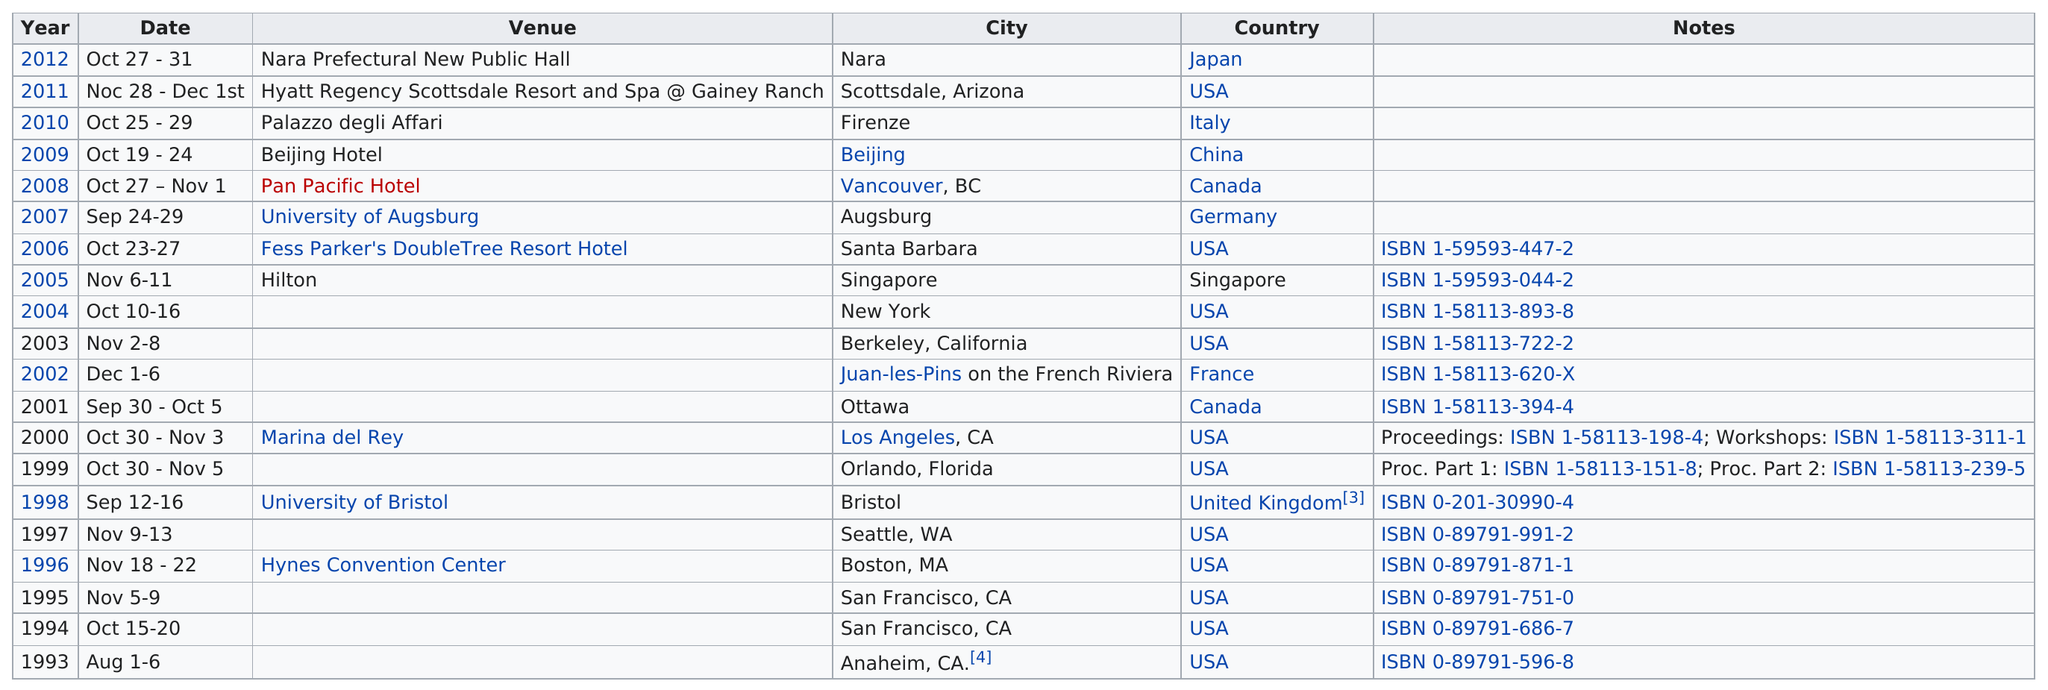Highlight a few significant elements in this photo. In 2012, the previous ACM Multimedia Workshop was held at the Nara Prefectural New Public Hall. In 2008 or 2010 was the conference longer? The chart lists a total of 9 countries. The conference is typically held in October, on average. The USA is listed as the country 11 times. 